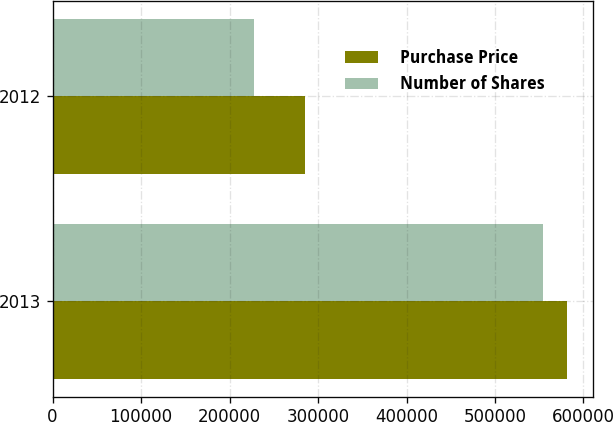Convert chart to OTSL. <chart><loc_0><loc_0><loc_500><loc_500><stacked_bar_chart><ecel><fcel>2013<fcel>2012<nl><fcel>Purchase Price<fcel>581387<fcel>285495<nl><fcel>Number of Shares<fcel>554491<fcel>227281<nl></chart> 